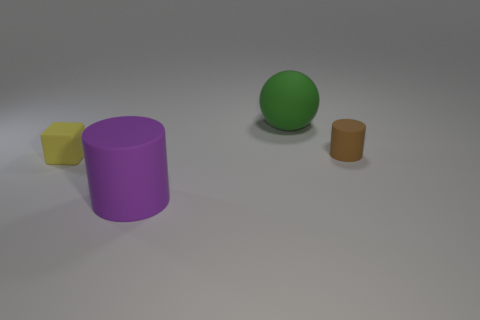Add 2 rubber balls. How many objects exist? 6 Subtract all balls. How many objects are left? 3 Subtract all large green rubber balls. Subtract all blue metallic cubes. How many objects are left? 3 Add 2 cubes. How many cubes are left? 3 Add 1 big yellow cubes. How many big yellow cubes exist? 1 Subtract 0 brown cubes. How many objects are left? 4 